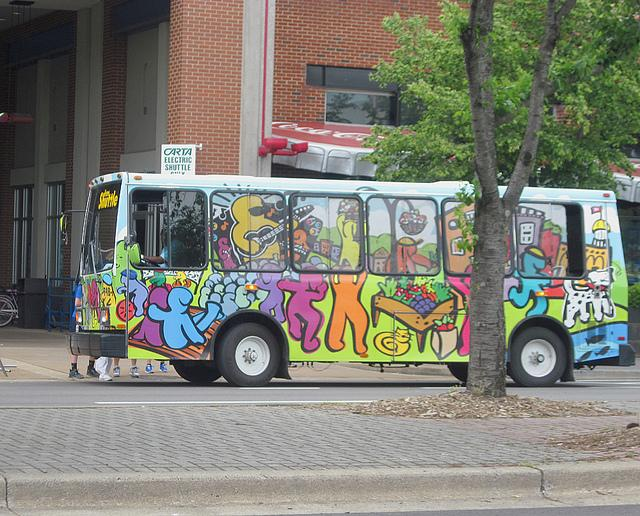What is the profession of the man seen on the bus? driver 